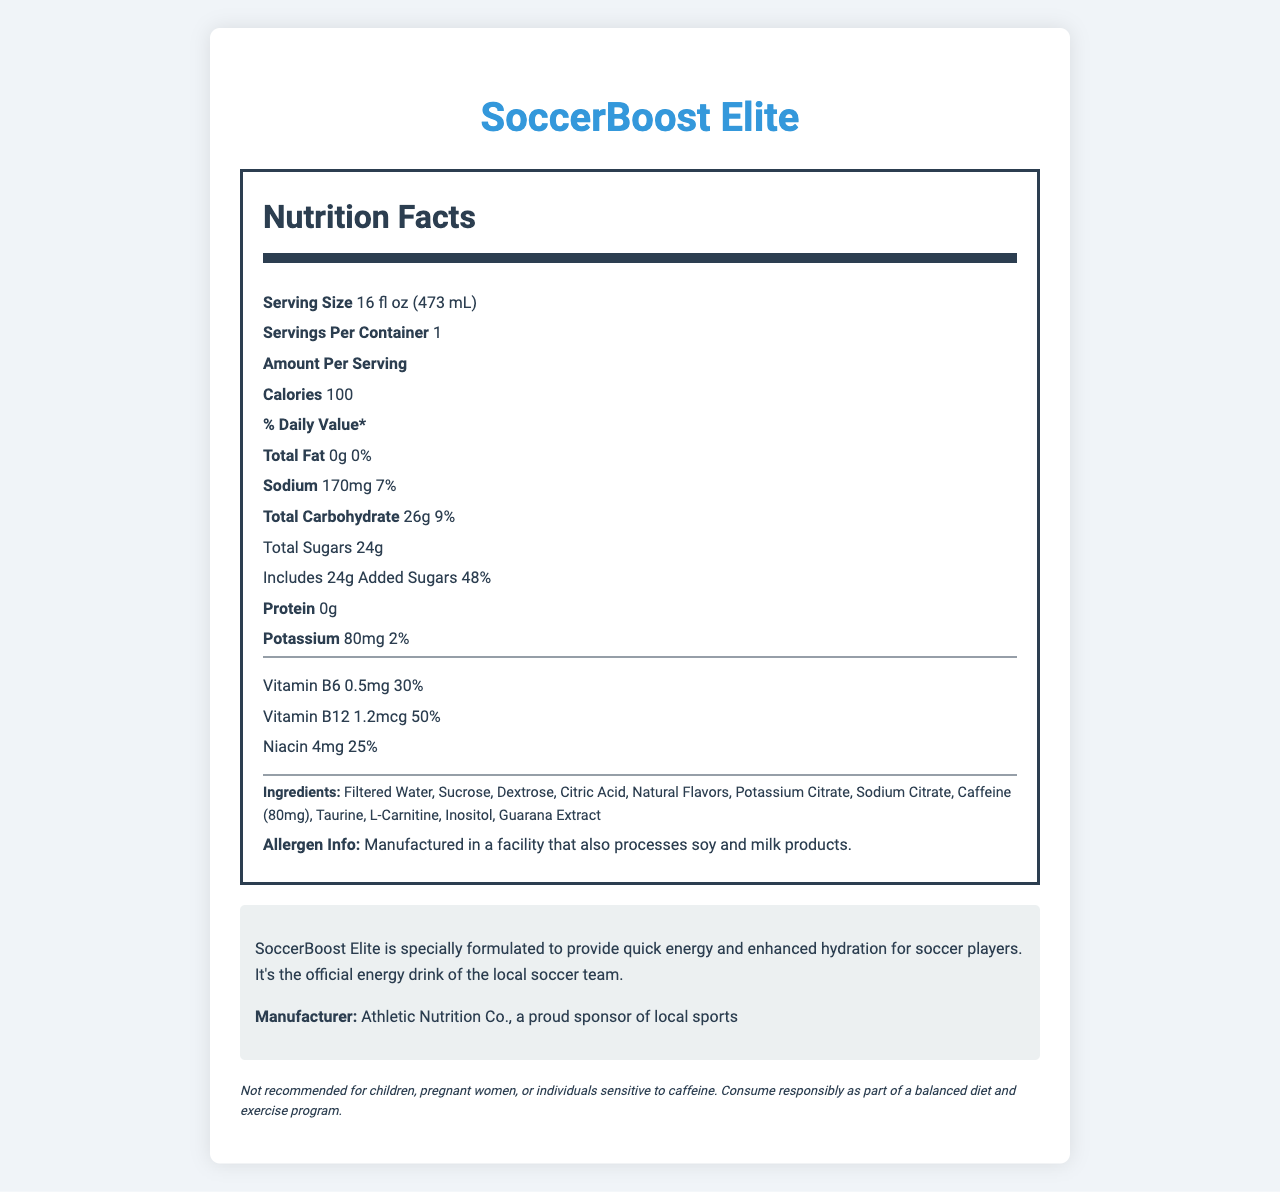what is the serving size of SoccerBoost Elite? The serving size is stated at the beginning of the nutrition facts section.
Answer: 16 fl oz (473 mL) how much sodium does one serving contain? The amount of sodium per serving is listed under the nutrition facts.
Answer: 170mg what is the percentage of daily value for added sugars in SoccerBoost Elite? The percentage of daily value for added sugars is provided next to the total sugars content.
Answer: 48% List the vitamins and their daily values included in SoccerBoost Elite? These percentages are listed under the vitamins and minerals section in the nutrition facts label.
Answer: Vitamin B6: 30%, Vitamin B12: 50%, Niacin: 25% what is the amount of caffeine in SoccerBoost Elite? Caffeine is mentioned in the list of other ingredients with its quantity.
Answer: 80mg Is SoccerBoost Elite suitable for children? The disclaimer at the bottom of the document states that it is not recommended for children.
Answer: No What is the role of SoccerBoost Elite for soccer players? A. Boost performance B. Provide quick energy and hydration C. Improve focus The consumer information section mentions that SoccerBoost Elite is specially formulated to provide quick energy and enhanced hydration for soccer players.
Answer: B How many servings are there in one container of SoccerBoost Elite? A. 1 B. 2 C. 3 The servings per container are listed as 1 in the nutrition facts label.
Answer: A Is there any fat in SoccerBoost Elite? The total fat listed is 0g which means there is no fat in the drink.
Answer: No Summarize the main idea of the document. The document provides detailed nutritional information about SoccerBoost Elite, highlighting its benefits for soccer players, the ingredients, and any necessary warnings.
Answer: SoccerBoost Elite is an energy drink designed specifically for soccer players to provide quick energy and enhanced hydration. It contains various ingredients, including vitamins and minerals, and is manufactured by Athletic Nutrition Co. The drink comes with a disclaimer about who should avoid consuming it. Does SoccerBoost Elite contain any allergens? The allergen information indicates that the drink is made in a facility that processes soy and milk products, which may be important for individuals with allergies.
Answer: Manufactured in a facility that processes soy and milk products. Can the exact taste of SoccerBoost Elite be determined from the document? The document doesn't provide information on the exact taste of the drink; it only mentions that it contains natural flavors.
Answer: Cannot be determined 